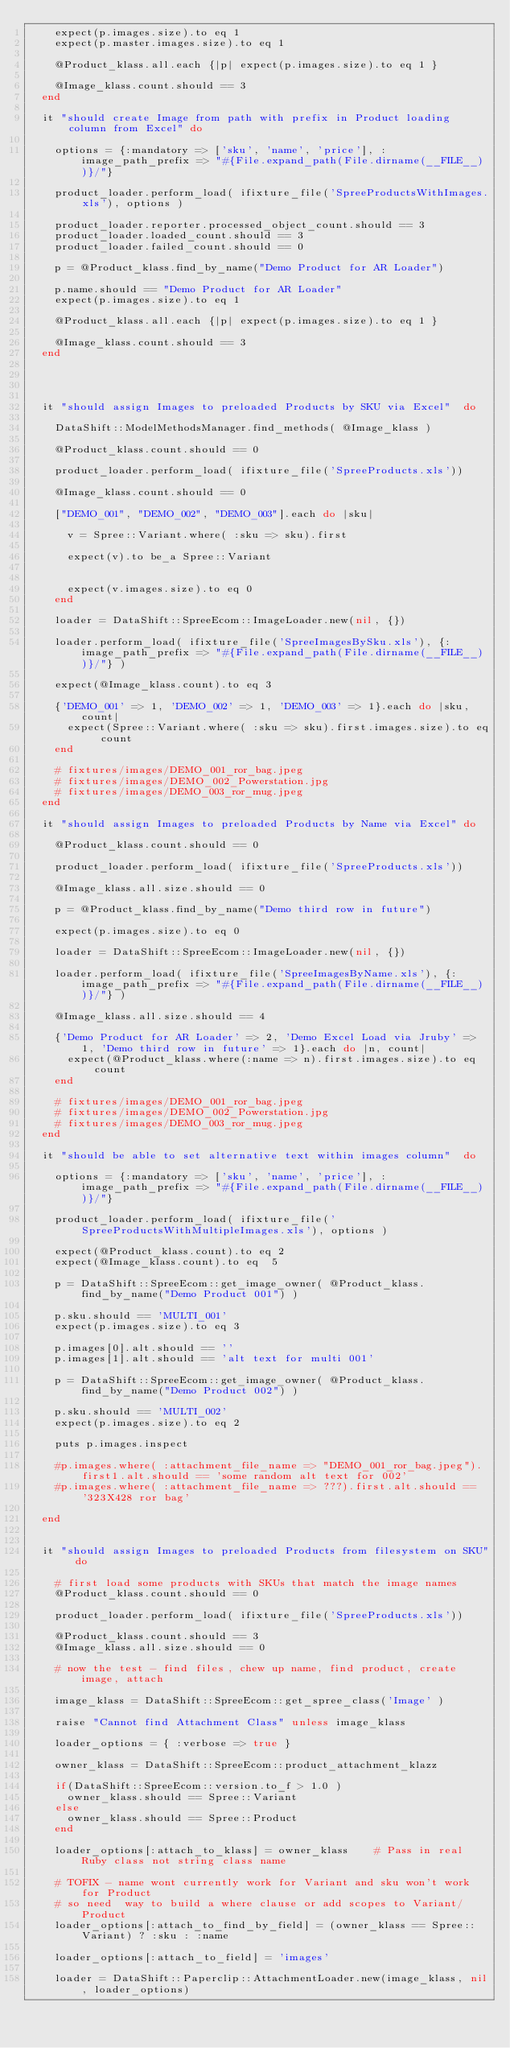<code> <loc_0><loc_0><loc_500><loc_500><_Ruby_>    expect(p.images.size).to eq 1
    expect(p.master.images.size).to eq 1

    @Product_klass.all.each {|p| expect(p.images.size).to eq 1 }

    @Image_klass.count.should == 3
  end

  it "should create Image from path with prefix in Product loading column from Excel" do

    options = {:mandatory => ['sku', 'name', 'price'], :image_path_prefix => "#{File.expand_path(File.dirname(__FILE__))}/"}

    product_loader.perform_load( ifixture_file('SpreeProductsWithImages.xls'), options )

    product_loader.reporter.processed_object_count.should == 3
    product_loader.loaded_count.should == 3
    product_loader.failed_count.should == 0

    p = @Product_klass.find_by_name("Demo Product for AR Loader")

    p.name.should == "Demo Product for AR Loader"
    expect(p.images.size).to eq 1

    @Product_klass.all.each {|p| expect(p.images.size).to eq 1 }

    @Image_klass.count.should == 3
  end




  it "should assign Images to preloaded Products by SKU via Excel"  do

    DataShift::ModelMethodsManager.find_methods( @Image_klass )

    @Product_klass.count.should == 0

    product_loader.perform_load( ifixture_file('SpreeProducts.xls'))

    @Image_klass.count.should == 0

    ["DEMO_001", "DEMO_002", "DEMO_003"].each do |sku|

      v = Spree::Variant.where( :sku => sku).first

      expect(v).to be_a Spree::Variant


      expect(v.images.size).to eq 0
    end

    loader = DataShift::SpreeEcom::ImageLoader.new(nil, {})

    loader.perform_load( ifixture_file('SpreeImagesBySku.xls'), {:image_path_prefix => "#{File.expand_path(File.dirname(__FILE__))}/"} )

    expect(@Image_klass.count).to eq 3

    {'DEMO_001' => 1, 'DEMO_002' => 1, 'DEMO_003' => 1}.each do |sku, count|
      expect(Spree::Variant.where( :sku => sku).first.images.size).to eq count
    end

    # fixtures/images/DEMO_001_ror_bag.jpeg
    # fixtures/images/DEMO_002_Powerstation.jpg
    # fixtures/images/DEMO_003_ror_mug.jpeg
  end

  it "should assign Images to preloaded Products by Name via Excel" do

    @Product_klass.count.should == 0

    product_loader.perform_load( ifixture_file('SpreeProducts.xls'))

    @Image_klass.all.size.should == 0

    p = @Product_klass.find_by_name("Demo third row in future")

    expect(p.images.size).to eq 0

    loader = DataShift::SpreeEcom::ImageLoader.new(nil, {})

    loader.perform_load( ifixture_file('SpreeImagesByName.xls'), {:image_path_prefix => "#{File.expand_path(File.dirname(__FILE__))}/"} )

    @Image_klass.all.size.should == 4

    {'Demo Product for AR Loader' => 2, 'Demo Excel Load via Jruby' => 1, 'Demo third row in future' => 1}.each do |n, count|
      expect(@Product_klass.where(:name => n).first.images.size).to eq count
    end

    # fixtures/images/DEMO_001_ror_bag.jpeg
    # fixtures/images/DEMO_002_Powerstation.jpg
    # fixtures/images/DEMO_003_ror_mug.jpeg
  end

  it "should be able to set alternative text within images column"  do

    options = {:mandatory => ['sku', 'name', 'price'], :image_path_prefix => "#{File.expand_path(File.dirname(__FILE__))}/"}

    product_loader.perform_load( ifixture_file('SpreeProductsWithMultipleImages.xls'), options )

    expect(@Product_klass.count).to eq 2
    expect(@Image_klass.count).to eq  5

    p = DataShift::SpreeEcom::get_image_owner( @Product_klass.find_by_name("Demo Product 001") )

    p.sku.should == 'MULTI_001'
    expect(p.images.size).to eq 3

    p.images[0].alt.should == ''
    p.images[1].alt.should == 'alt text for multi 001'

    p = DataShift::SpreeEcom::get_image_owner( @Product_klass.find_by_name("Demo Product 002") )

    p.sku.should == 'MULTI_002'
    expect(p.images.size).to eq 2

    puts p.images.inspect

    #p.images.where( :attachment_file_name => "DEMO_001_ror_bag.jpeg").first1.alt.should == 'some random alt text for 002'
    #p.images.where( :attachment_file_name => ???).first.alt.should == '323X428 ror bag'

  end


  it "should assign Images to preloaded Products from filesystem on SKU" do

    # first load some products with SKUs that match the image names
    @Product_klass.count.should == 0

    product_loader.perform_load( ifixture_file('SpreeProducts.xls'))

    @Product_klass.count.should == 3
    @Image_klass.all.size.should == 0

    # now the test - find files, chew up name, find product, create image, attach

    image_klass = DataShift::SpreeEcom::get_spree_class('Image' )

    raise "Cannot find Attachment Class" unless image_klass

    loader_options = { :verbose => true }

    owner_klass = DataShift::SpreeEcom::product_attachment_klazz

    if(DataShift::SpreeEcom::version.to_f > 1.0 )
      owner_klass.should == Spree::Variant
    else
      owner_klass.should == Spree::Product
    end

    loader_options[:attach_to_klass] = owner_klass    # Pass in real Ruby class not string class name

    # TOFIX - name wont currently work for Variant and sku won't work for Product
    # so need  way to build a where clause or add scopes to Variant/Product
    loader_options[:attach_to_find_by_field] = (owner_klass == Spree::Variant) ? :sku : :name

    loader_options[:attach_to_field] = 'images'

    loader = DataShift::Paperclip::AttachmentLoader.new(image_klass, nil, loader_options)
</code> 